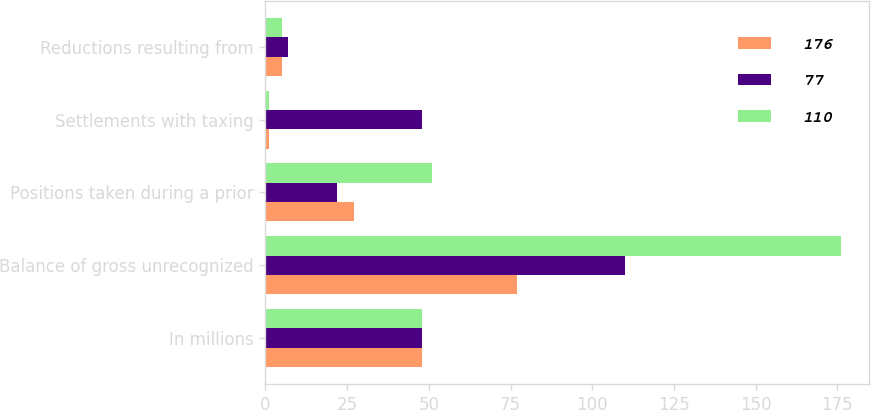Convert chart to OTSL. <chart><loc_0><loc_0><loc_500><loc_500><stacked_bar_chart><ecel><fcel>In millions<fcel>Balance of gross unrecognized<fcel>Positions taken during a prior<fcel>Settlements with taxing<fcel>Reductions resulting from<nl><fcel>176<fcel>48<fcel>77<fcel>27<fcel>1<fcel>5<nl><fcel>77<fcel>48<fcel>110<fcel>22<fcel>48<fcel>7<nl><fcel>110<fcel>48<fcel>176<fcel>51<fcel>1<fcel>5<nl></chart> 